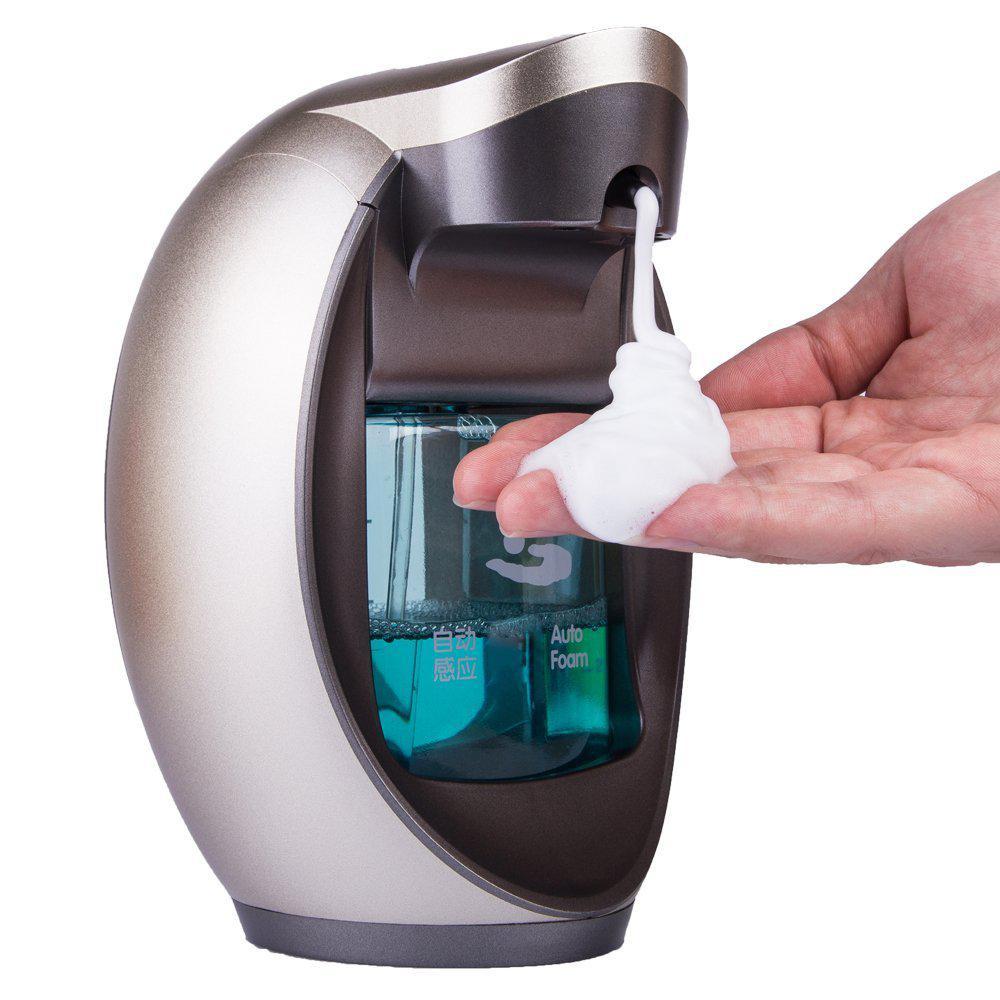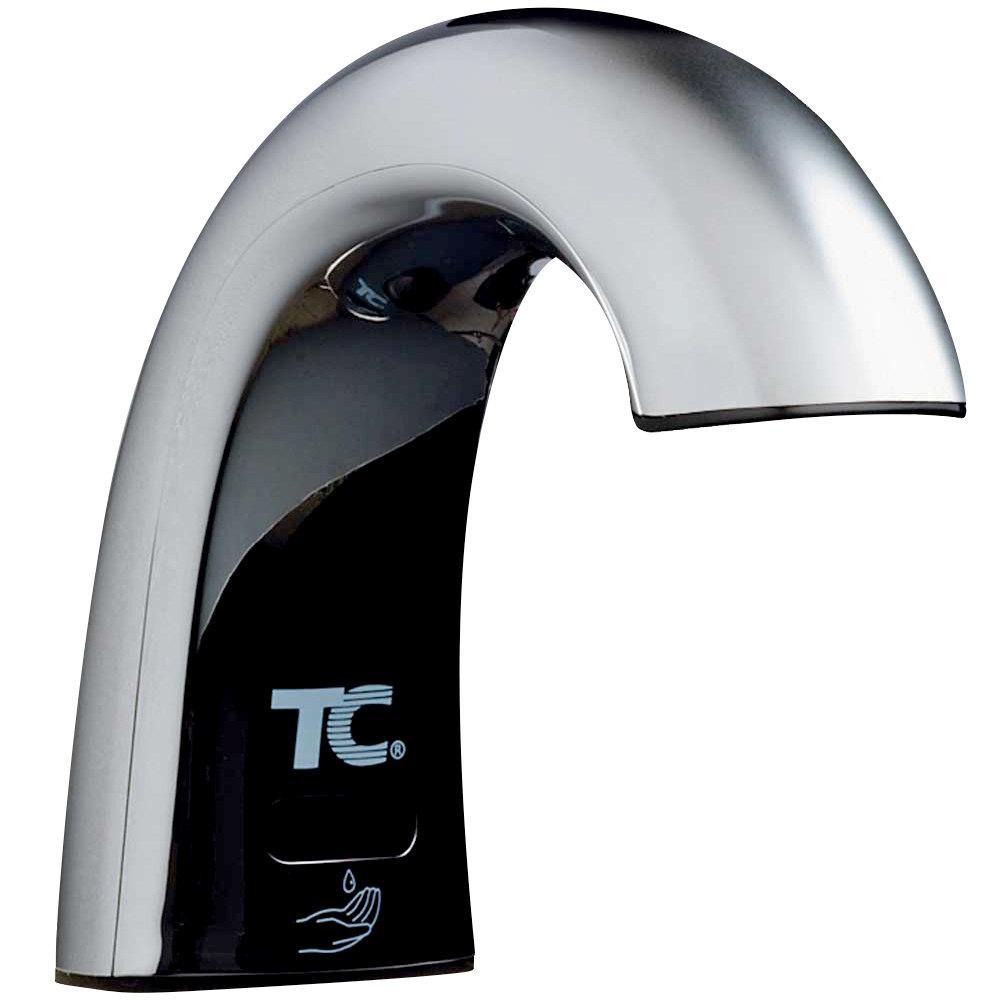The first image is the image on the left, the second image is the image on the right. For the images shown, is this caption "There is a human hand in the image on the left." true? Answer yes or no. Yes. 